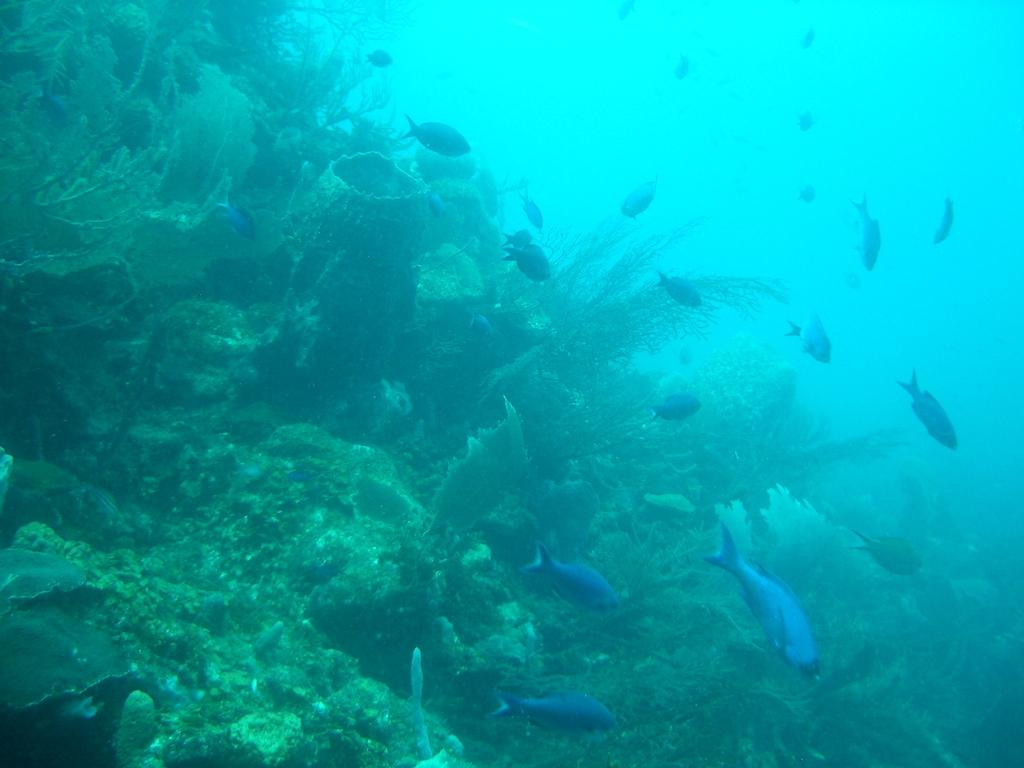What type of environment is shown in the image? The image depicts an underwater environment. What can be seen growing in the underwater environment? There are plants visible in the image. What type of animals can be seen in the underwater environment? There are fishes present in the image. What type of crown can be seen on the fish in the image? There is no crown present on any fish in the image; the fishes are depicted in their natural state. 